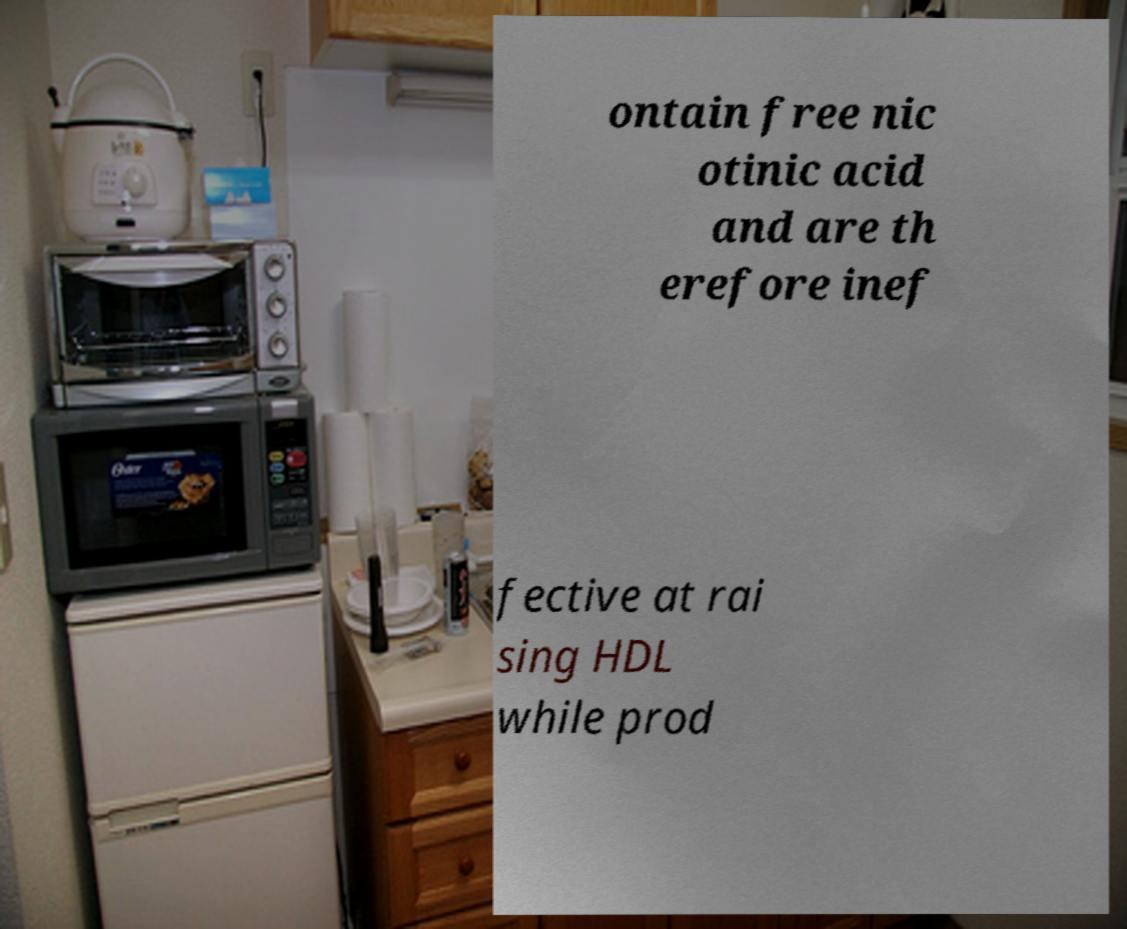Could you assist in decoding the text presented in this image and type it out clearly? ontain free nic otinic acid and are th erefore inef fective at rai sing HDL while prod 